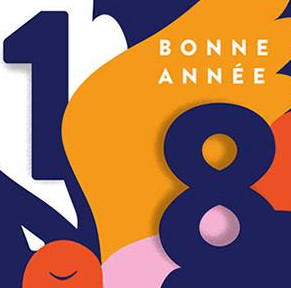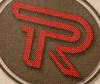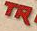What text appears in these images from left to right, separated by a semicolon? 18; R; TR 